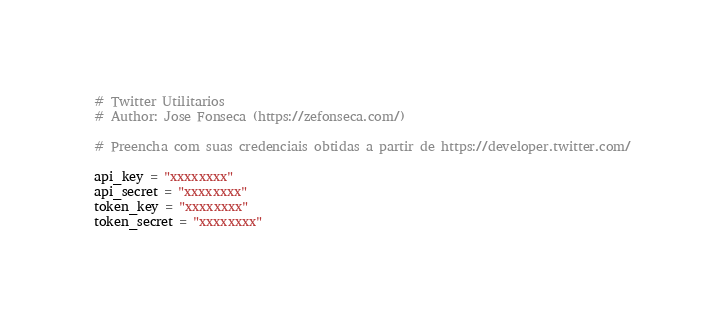Convert code to text. <code><loc_0><loc_0><loc_500><loc_500><_Python_># Twitter Utilitarios
# Author: Jose Fonseca (https://zefonseca.com/)

# Preencha com suas credenciais obtidas a partir de https://developer.twitter.com/

api_key = "xxxxxxxx"
api_secret = "xxxxxxxx"
token_key = "xxxxxxxx"
token_secret = "xxxxxxxx"

</code> 